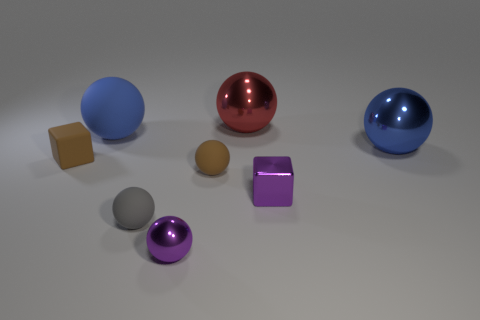What number of things are either tiny cubes to the right of the tiny shiny ball or blue metallic objects?
Provide a succinct answer. 2. Are there any other rubber spheres of the same size as the gray rubber sphere?
Offer a terse response. Yes. There is a large blue thing that is on the left side of the blue metal sphere; is there a block that is left of it?
Offer a very short reply. Yes. What number of blocks are small metallic things or brown things?
Ensure brevity in your answer.  2. Is there a red shiny object of the same shape as the tiny gray rubber thing?
Provide a succinct answer. Yes. The tiny gray object has what shape?
Offer a very short reply. Sphere. How many things are either big blue cubes or big blue spheres?
Give a very brief answer. 2. There is a purple shiny object that is on the left side of the large red metal ball; is its size the same as the rubber object to the right of the gray rubber thing?
Your answer should be compact. Yes. Are there more brown blocks in front of the large blue shiny sphere than small shiny cubes that are to the left of the tiny gray matte ball?
Your answer should be compact. Yes. What material is the tiny brown thing right of the tiny brown cube?
Your answer should be compact. Rubber. 